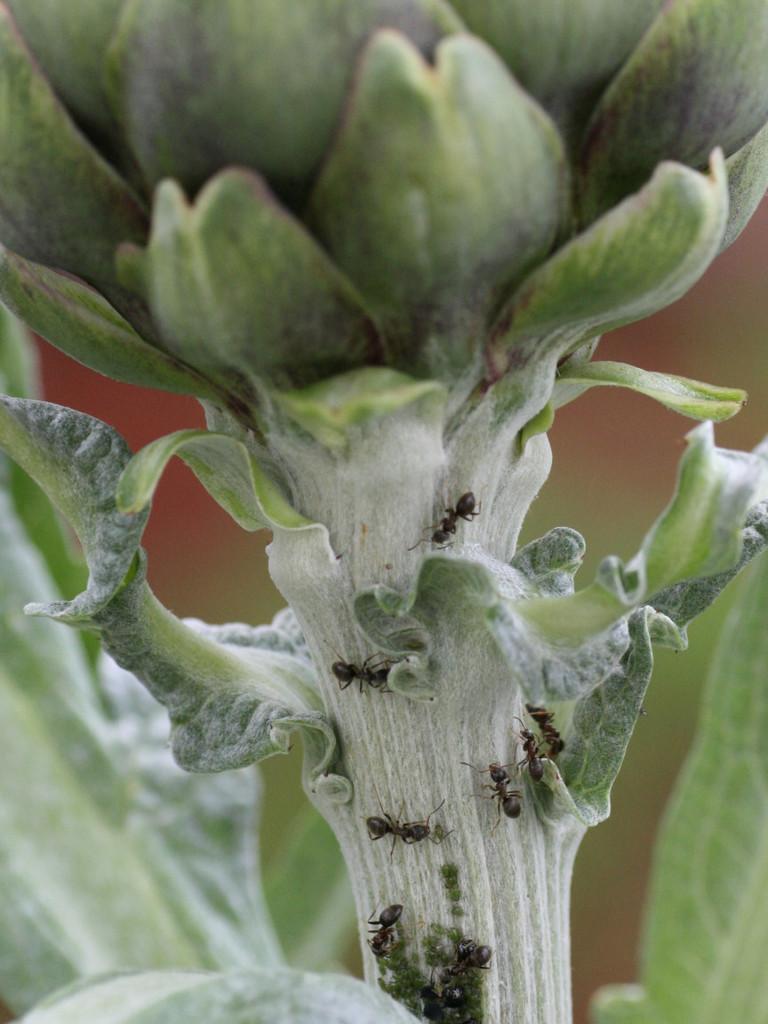Can you describe this image briefly? In this image we can see some plants on the surface and some black ants on the plant stem. 